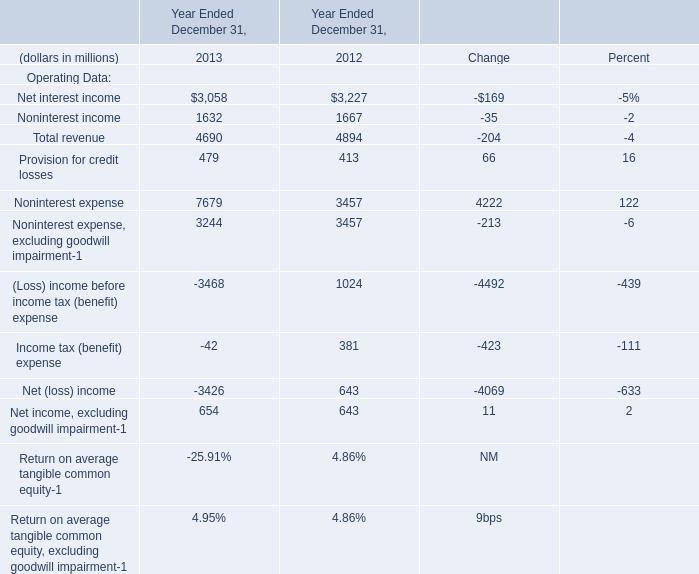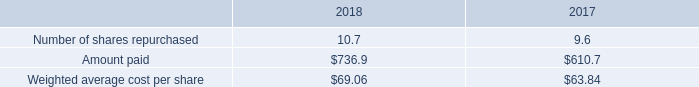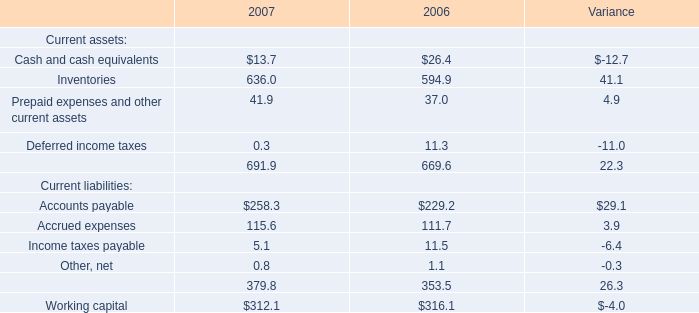what was the total cash dividend declared from 2016 to 2018 
Computations: (423.8 + (468.4 + 446.3))
Answer: 1338.5. 